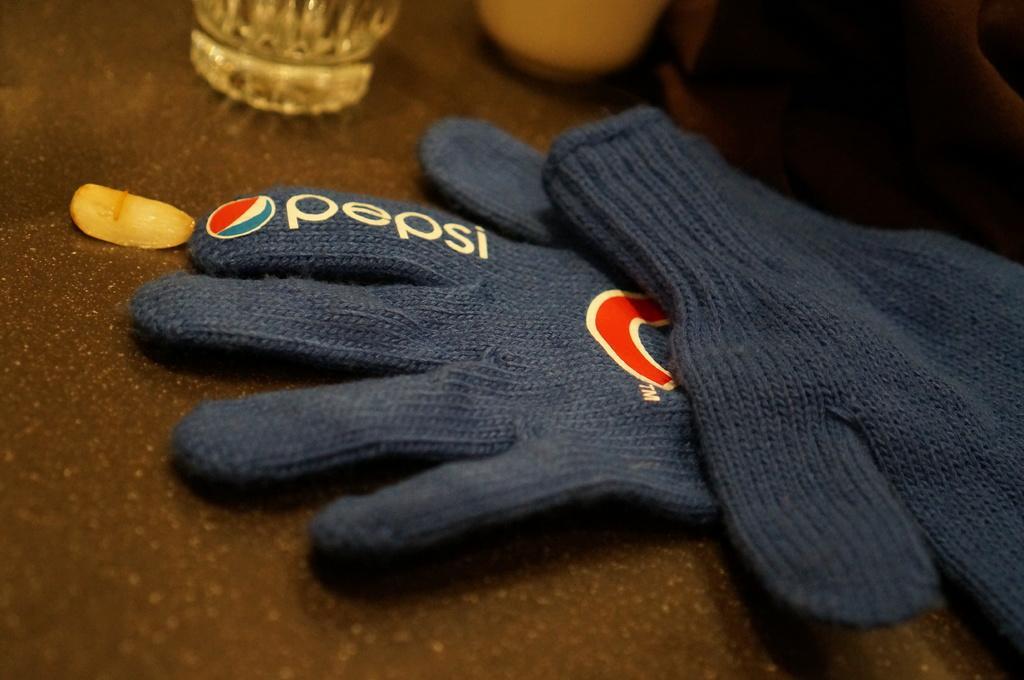Can you describe this image briefly? In this picture, we see a brown table on which the blue color gloves, glass and a white color object. In the right top, it is brown in color. 